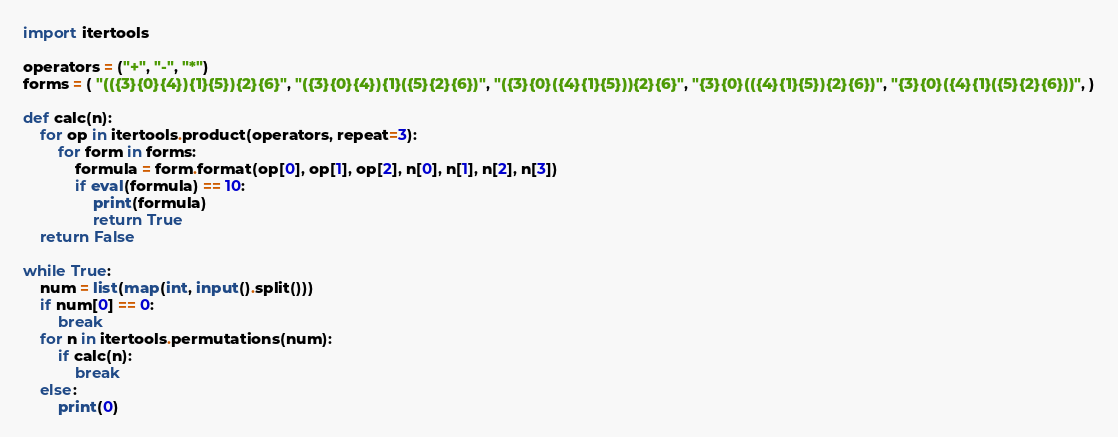Convert code to text. <code><loc_0><loc_0><loc_500><loc_500><_Python_>import itertools

operators = ("+", "-", "*")
forms = ( "(({3}{0}{4}){1}{5}){2}{6}", "({3}{0}{4}){1}({5}{2}{6})", "({3}{0}({4}{1}{5})){2}{6}", "{3}{0}(({4}{1}{5}){2}{6})", "{3}{0}({4}{1}({5}{2}{6}))", )

def calc(n):
    for op in itertools.product(operators, repeat=3):
        for form in forms:
            formula = form.format(op[0], op[1], op[2], n[0], n[1], n[2], n[3])
            if eval(formula) == 10:
                print(formula)
                return True
    return False

while True:
    num = list(map(int, input().split()))
    if num[0] == 0:
        break
    for n in itertools.permutations(num):
        if calc(n):
            break
    else:
        print(0)

</code> 